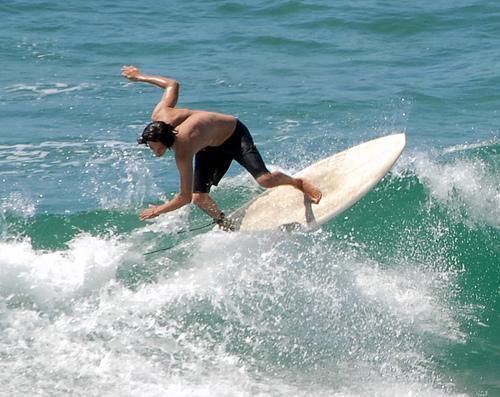How many people are in the picture?
Give a very brief answer. 1. 